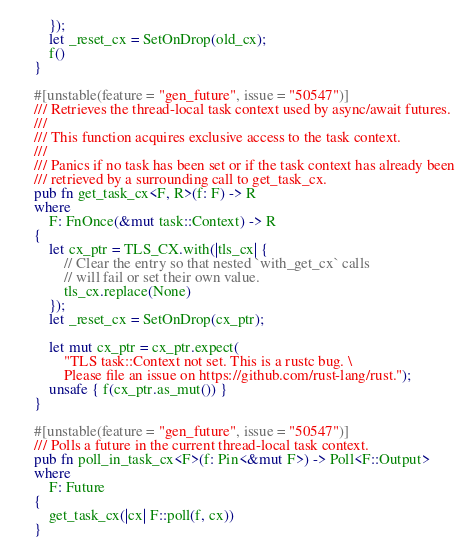<code> <loc_0><loc_0><loc_500><loc_500><_Rust_>    });
    let _reset_cx = SetOnDrop(old_cx);
    f()
}

#[unstable(feature = "gen_future", issue = "50547")]
/// Retrieves the thread-local task context used by async/await futures.
///
/// This function acquires exclusive access to the task context.
///
/// Panics if no task has been set or if the task context has already been
/// retrieved by a surrounding call to get_task_cx.
pub fn get_task_cx<F, R>(f: F) -> R
where
    F: FnOnce(&mut task::Context) -> R
{
    let cx_ptr = TLS_CX.with(|tls_cx| {
        // Clear the entry so that nested `with_get_cx` calls
        // will fail or set their own value.
        tls_cx.replace(None)
    });
    let _reset_cx = SetOnDrop(cx_ptr);

    let mut cx_ptr = cx_ptr.expect(
        "TLS task::Context not set. This is a rustc bug. \
        Please file an issue on https://github.com/rust-lang/rust.");
    unsafe { f(cx_ptr.as_mut()) }
}

#[unstable(feature = "gen_future", issue = "50547")]
/// Polls a future in the current thread-local task context.
pub fn poll_in_task_cx<F>(f: Pin<&mut F>) -> Poll<F::Output>
where
    F: Future
{
    get_task_cx(|cx| F::poll(f, cx))
}
</code> 